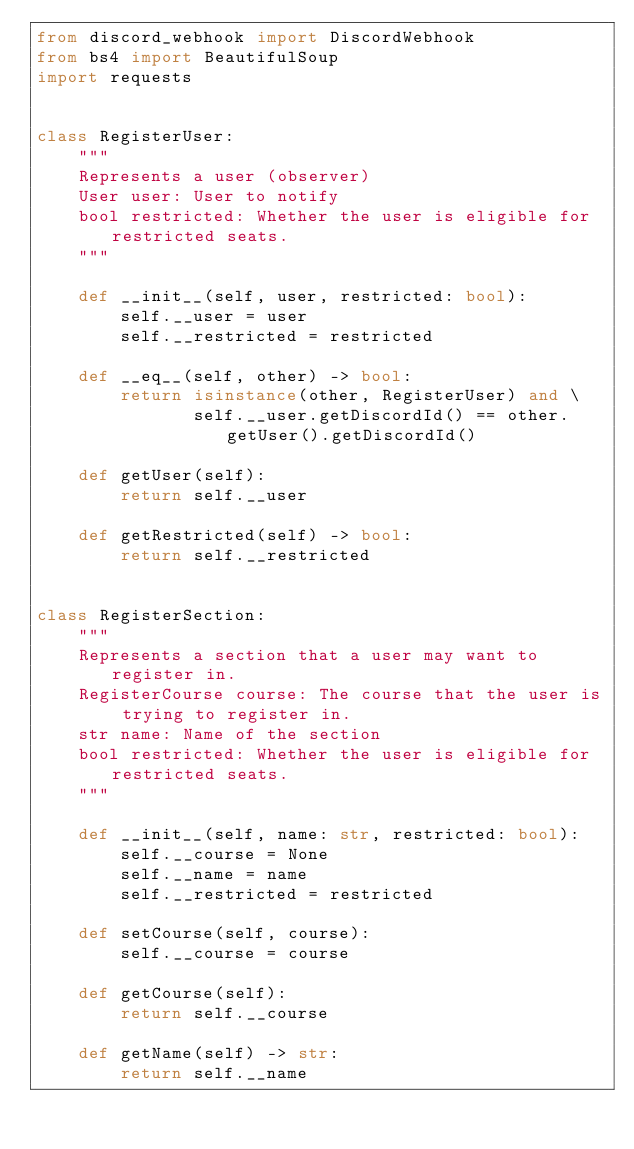<code> <loc_0><loc_0><loc_500><loc_500><_Python_>from discord_webhook import DiscordWebhook
from bs4 import BeautifulSoup
import requests


class RegisterUser:
    """
    Represents a user (observer)
    User user: User to notify
    bool restricted: Whether the user is eligible for restricted seats.
    """

    def __init__(self, user, restricted: bool):
        self.__user = user
        self.__restricted = restricted

    def __eq__(self, other) -> bool:
        return isinstance(other, RegisterUser) and \
               self.__user.getDiscordId() == other.getUser().getDiscordId()

    def getUser(self):
        return self.__user

    def getRestricted(self) -> bool:
        return self.__restricted


class RegisterSection:
    """
    Represents a section that a user may want to register in.
    RegisterCourse course: The course that the user is trying to register in.
    str name: Name of the section
    bool restricted: Whether the user is eligible for restricted seats.
    """

    def __init__(self, name: str, restricted: bool):
        self.__course = None
        self.__name = name
        self.__restricted = restricted

    def setCourse(self, course):
        self.__course = course

    def getCourse(self):
        return self.__course

    def getName(self) -> str:
        return self.__name</code> 